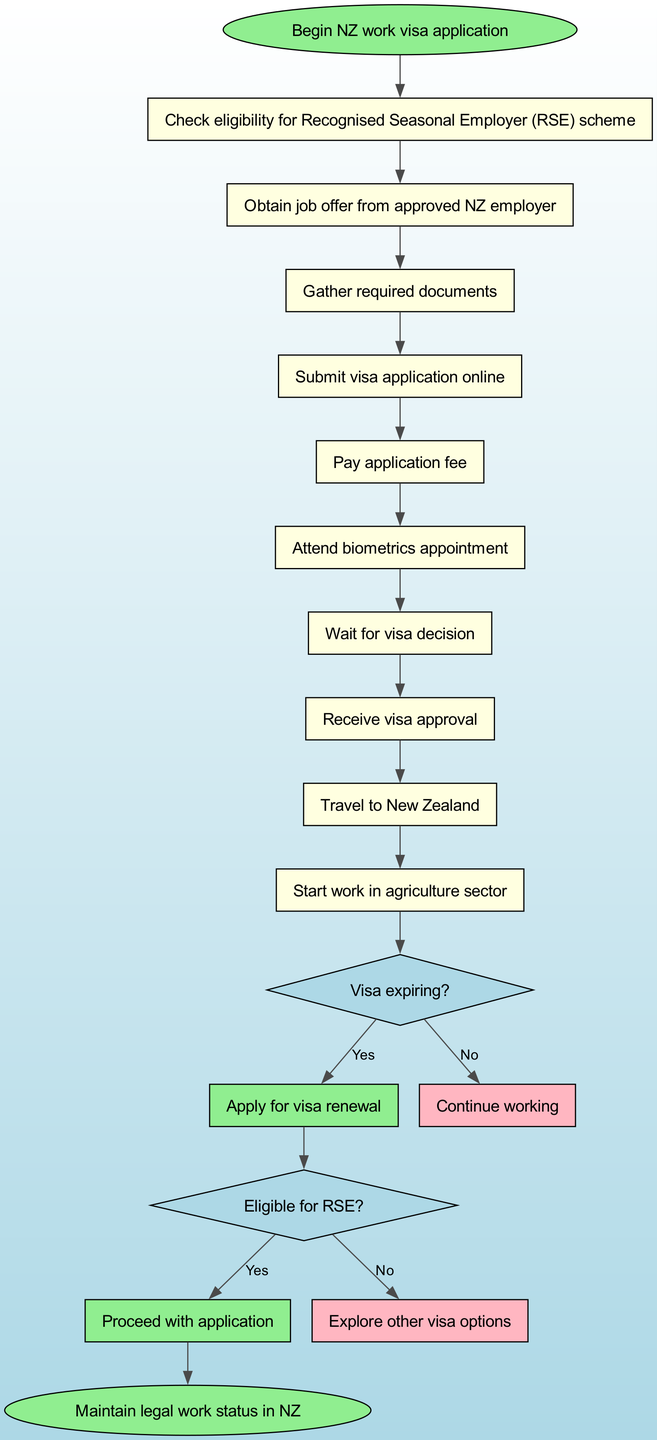What is the first step in the NZ work visa application process? The first step, indicated by the starting point of the flow chart, is to "Begin NZ work visa application".
Answer: Begin NZ work visa application How many nodes are in the process? There are a total of 12 nodes, including the start and end nodes, as well as the main flow and conditional nodes.
Answer: 12 What happens if the visa is expiring? If the visa is expiring, according to the flow chart, the next step is to "Apply for visa renewal".
Answer: Apply for visa renewal What is required to proceed with the application? To proceed with the application, the condition states that one must be "Eligible for RSE".
Answer: Eligible for RSE If a person is not eligible for the RSE, what should they do next? If not eligible for the RSE, the flow chart indicates to "Explore other visa options".
Answer: Explore other visa options What is the last step before ending the process? The last step before ending the process is "Start work in agriculture sector".
Answer: Start work in agriculture sector How many conditional nodes are there? There are 2 conditional nodes in the flow chart, each representing a decision point in the process.
Answer: 2 What is the color of the end node? The end node is colored light green, as indicated in the diagram's design.
Answer: Light green What do you do after receiving visa approval? After receiving visa approval, the next step is to "Travel to New Zealand".
Answer: Travel to New Zealand 